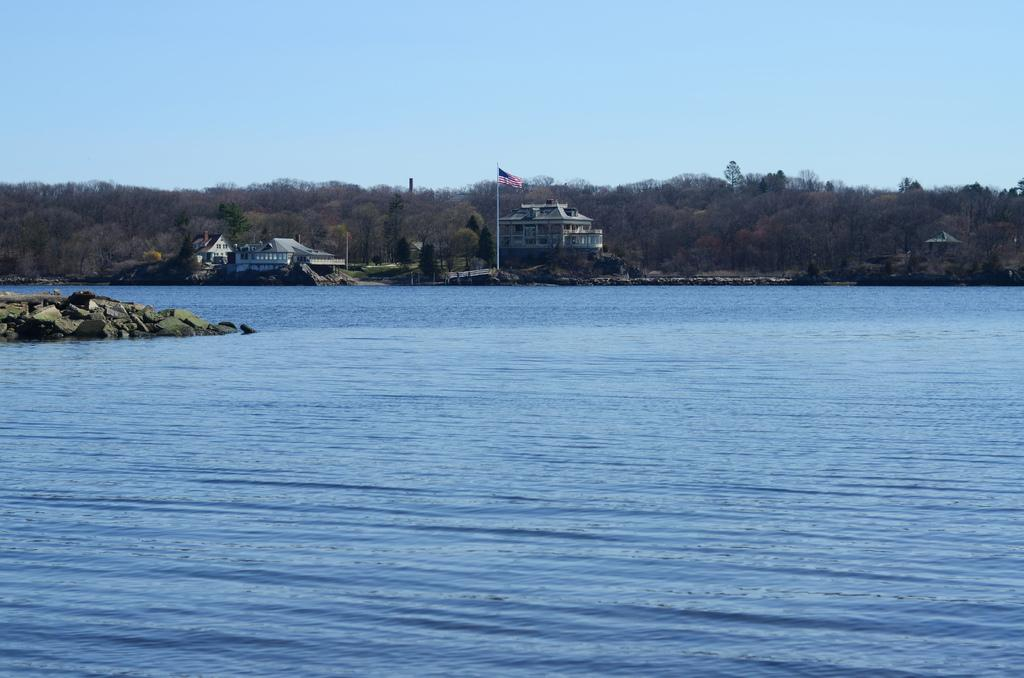What is the primary element in the image? There is water in the image. What other objects or features can be seen in the image? There are rocks in the image. What can be seen in the background of the image? There are trees, buildings, and a flag in the background of the image. Where is the cushion located in the image? There is no cushion present in the image. 